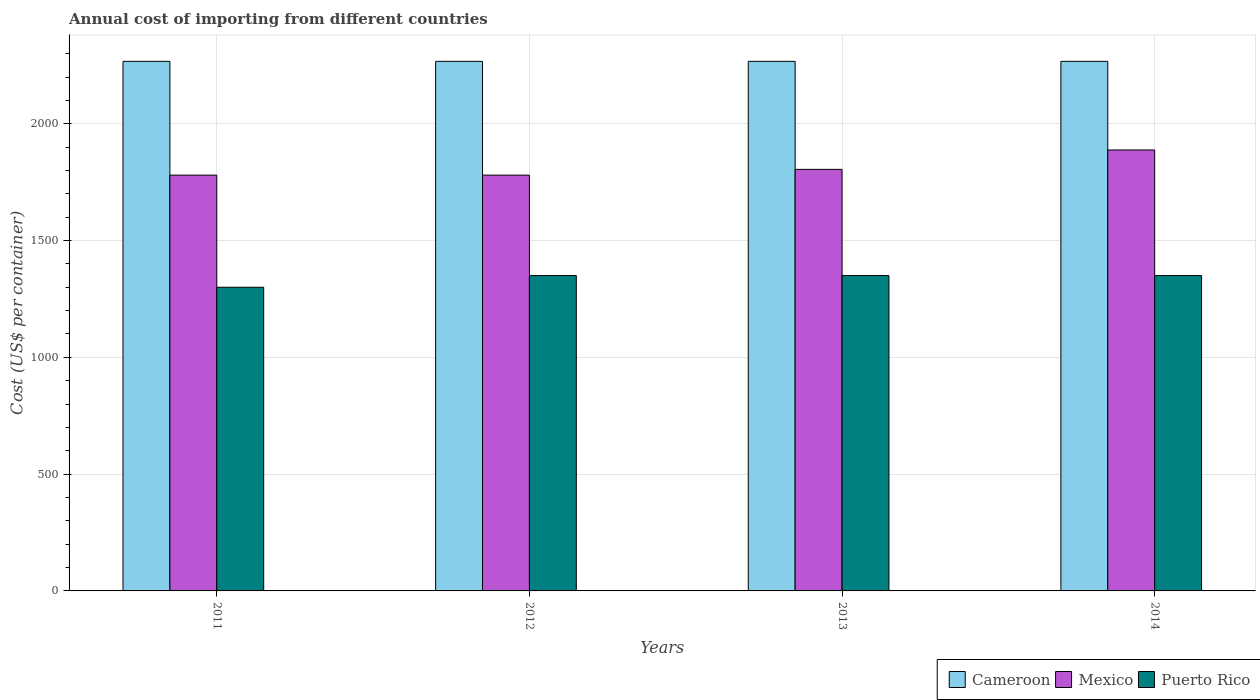How many groups of bars are there?
Give a very brief answer. 4. Are the number of bars per tick equal to the number of legend labels?
Provide a succinct answer. Yes. How many bars are there on the 2nd tick from the left?
Ensure brevity in your answer.  3. How many bars are there on the 1st tick from the right?
Ensure brevity in your answer.  3. What is the label of the 2nd group of bars from the left?
Your answer should be compact. 2012. In how many cases, is the number of bars for a given year not equal to the number of legend labels?
Your answer should be compact. 0. What is the total annual cost of importing in Cameroon in 2012?
Ensure brevity in your answer.  2267. Across all years, what is the maximum total annual cost of importing in Puerto Rico?
Make the answer very short. 1350. Across all years, what is the minimum total annual cost of importing in Cameroon?
Your response must be concise. 2267. What is the total total annual cost of importing in Cameroon in the graph?
Ensure brevity in your answer.  9068. What is the difference between the total annual cost of importing in Puerto Rico in 2013 and that in 2014?
Your answer should be very brief. 0. What is the difference between the total annual cost of importing in Mexico in 2012 and the total annual cost of importing in Puerto Rico in 2013?
Provide a short and direct response. 430. What is the average total annual cost of importing in Puerto Rico per year?
Provide a succinct answer. 1337.5. In the year 2011, what is the difference between the total annual cost of importing in Mexico and total annual cost of importing in Puerto Rico?
Make the answer very short. 480. Is the total annual cost of importing in Puerto Rico in 2011 less than that in 2014?
Offer a very short reply. Yes. Is the difference between the total annual cost of importing in Mexico in 2012 and 2013 greater than the difference between the total annual cost of importing in Puerto Rico in 2012 and 2013?
Give a very brief answer. No. What is the difference between the highest and the second highest total annual cost of importing in Puerto Rico?
Provide a short and direct response. 0. What is the difference between the highest and the lowest total annual cost of importing in Mexico?
Offer a terse response. 107.6. In how many years, is the total annual cost of importing in Mexico greater than the average total annual cost of importing in Mexico taken over all years?
Make the answer very short. 1. What does the 2nd bar from the left in 2013 represents?
Your answer should be compact. Mexico. What does the 1st bar from the right in 2014 represents?
Offer a terse response. Puerto Rico. Is it the case that in every year, the sum of the total annual cost of importing in Cameroon and total annual cost of importing in Mexico is greater than the total annual cost of importing in Puerto Rico?
Provide a short and direct response. Yes. How many bars are there?
Your answer should be compact. 12. Does the graph contain any zero values?
Make the answer very short. No. Where does the legend appear in the graph?
Make the answer very short. Bottom right. How many legend labels are there?
Your answer should be compact. 3. How are the legend labels stacked?
Offer a terse response. Horizontal. What is the title of the graph?
Provide a succinct answer. Annual cost of importing from different countries. Does "Brazil" appear as one of the legend labels in the graph?
Offer a very short reply. No. What is the label or title of the Y-axis?
Provide a short and direct response. Cost (US$ per container). What is the Cost (US$ per container) in Cameroon in 2011?
Make the answer very short. 2267. What is the Cost (US$ per container) in Mexico in 2011?
Offer a very short reply. 1780. What is the Cost (US$ per container) in Puerto Rico in 2011?
Provide a succinct answer. 1300. What is the Cost (US$ per container) in Cameroon in 2012?
Offer a terse response. 2267. What is the Cost (US$ per container) in Mexico in 2012?
Keep it short and to the point. 1780. What is the Cost (US$ per container) of Puerto Rico in 2012?
Offer a very short reply. 1350. What is the Cost (US$ per container) of Cameroon in 2013?
Provide a succinct answer. 2267. What is the Cost (US$ per container) of Mexico in 2013?
Provide a succinct answer. 1804.6. What is the Cost (US$ per container) in Puerto Rico in 2013?
Provide a short and direct response. 1350. What is the Cost (US$ per container) in Cameroon in 2014?
Keep it short and to the point. 2267. What is the Cost (US$ per container) in Mexico in 2014?
Make the answer very short. 1887.6. What is the Cost (US$ per container) in Puerto Rico in 2014?
Keep it short and to the point. 1350. Across all years, what is the maximum Cost (US$ per container) of Cameroon?
Make the answer very short. 2267. Across all years, what is the maximum Cost (US$ per container) in Mexico?
Your answer should be very brief. 1887.6. Across all years, what is the maximum Cost (US$ per container) in Puerto Rico?
Provide a succinct answer. 1350. Across all years, what is the minimum Cost (US$ per container) of Cameroon?
Your answer should be very brief. 2267. Across all years, what is the minimum Cost (US$ per container) of Mexico?
Keep it short and to the point. 1780. Across all years, what is the minimum Cost (US$ per container) in Puerto Rico?
Make the answer very short. 1300. What is the total Cost (US$ per container) of Cameroon in the graph?
Give a very brief answer. 9068. What is the total Cost (US$ per container) in Mexico in the graph?
Offer a very short reply. 7252.2. What is the total Cost (US$ per container) of Puerto Rico in the graph?
Provide a short and direct response. 5350. What is the difference between the Cost (US$ per container) of Cameroon in 2011 and that in 2012?
Provide a succinct answer. 0. What is the difference between the Cost (US$ per container) of Puerto Rico in 2011 and that in 2012?
Your answer should be compact. -50. What is the difference between the Cost (US$ per container) in Cameroon in 2011 and that in 2013?
Your response must be concise. 0. What is the difference between the Cost (US$ per container) of Mexico in 2011 and that in 2013?
Keep it short and to the point. -24.6. What is the difference between the Cost (US$ per container) in Puerto Rico in 2011 and that in 2013?
Your answer should be compact. -50. What is the difference between the Cost (US$ per container) of Mexico in 2011 and that in 2014?
Give a very brief answer. -107.6. What is the difference between the Cost (US$ per container) in Puerto Rico in 2011 and that in 2014?
Provide a succinct answer. -50. What is the difference between the Cost (US$ per container) in Mexico in 2012 and that in 2013?
Keep it short and to the point. -24.6. What is the difference between the Cost (US$ per container) of Cameroon in 2012 and that in 2014?
Make the answer very short. 0. What is the difference between the Cost (US$ per container) of Mexico in 2012 and that in 2014?
Keep it short and to the point. -107.6. What is the difference between the Cost (US$ per container) of Mexico in 2013 and that in 2014?
Offer a very short reply. -83. What is the difference between the Cost (US$ per container) of Puerto Rico in 2013 and that in 2014?
Your response must be concise. 0. What is the difference between the Cost (US$ per container) of Cameroon in 2011 and the Cost (US$ per container) of Mexico in 2012?
Offer a terse response. 487. What is the difference between the Cost (US$ per container) in Cameroon in 2011 and the Cost (US$ per container) in Puerto Rico in 2012?
Your answer should be very brief. 917. What is the difference between the Cost (US$ per container) in Mexico in 2011 and the Cost (US$ per container) in Puerto Rico in 2012?
Keep it short and to the point. 430. What is the difference between the Cost (US$ per container) in Cameroon in 2011 and the Cost (US$ per container) in Mexico in 2013?
Give a very brief answer. 462.4. What is the difference between the Cost (US$ per container) of Cameroon in 2011 and the Cost (US$ per container) of Puerto Rico in 2013?
Make the answer very short. 917. What is the difference between the Cost (US$ per container) of Mexico in 2011 and the Cost (US$ per container) of Puerto Rico in 2013?
Keep it short and to the point. 430. What is the difference between the Cost (US$ per container) in Cameroon in 2011 and the Cost (US$ per container) in Mexico in 2014?
Offer a terse response. 379.4. What is the difference between the Cost (US$ per container) of Cameroon in 2011 and the Cost (US$ per container) of Puerto Rico in 2014?
Give a very brief answer. 917. What is the difference between the Cost (US$ per container) of Mexico in 2011 and the Cost (US$ per container) of Puerto Rico in 2014?
Your answer should be compact. 430. What is the difference between the Cost (US$ per container) of Cameroon in 2012 and the Cost (US$ per container) of Mexico in 2013?
Ensure brevity in your answer.  462.4. What is the difference between the Cost (US$ per container) of Cameroon in 2012 and the Cost (US$ per container) of Puerto Rico in 2013?
Offer a terse response. 917. What is the difference between the Cost (US$ per container) in Mexico in 2012 and the Cost (US$ per container) in Puerto Rico in 2013?
Ensure brevity in your answer.  430. What is the difference between the Cost (US$ per container) of Cameroon in 2012 and the Cost (US$ per container) of Mexico in 2014?
Provide a succinct answer. 379.4. What is the difference between the Cost (US$ per container) in Cameroon in 2012 and the Cost (US$ per container) in Puerto Rico in 2014?
Your response must be concise. 917. What is the difference between the Cost (US$ per container) in Mexico in 2012 and the Cost (US$ per container) in Puerto Rico in 2014?
Make the answer very short. 430. What is the difference between the Cost (US$ per container) of Cameroon in 2013 and the Cost (US$ per container) of Mexico in 2014?
Provide a succinct answer. 379.4. What is the difference between the Cost (US$ per container) of Cameroon in 2013 and the Cost (US$ per container) of Puerto Rico in 2014?
Your response must be concise. 917. What is the difference between the Cost (US$ per container) of Mexico in 2013 and the Cost (US$ per container) of Puerto Rico in 2014?
Offer a very short reply. 454.6. What is the average Cost (US$ per container) in Cameroon per year?
Provide a short and direct response. 2267. What is the average Cost (US$ per container) of Mexico per year?
Offer a terse response. 1813.05. What is the average Cost (US$ per container) of Puerto Rico per year?
Your answer should be very brief. 1337.5. In the year 2011, what is the difference between the Cost (US$ per container) in Cameroon and Cost (US$ per container) in Mexico?
Your response must be concise. 487. In the year 2011, what is the difference between the Cost (US$ per container) of Cameroon and Cost (US$ per container) of Puerto Rico?
Offer a terse response. 967. In the year 2011, what is the difference between the Cost (US$ per container) in Mexico and Cost (US$ per container) in Puerto Rico?
Your response must be concise. 480. In the year 2012, what is the difference between the Cost (US$ per container) in Cameroon and Cost (US$ per container) in Mexico?
Make the answer very short. 487. In the year 2012, what is the difference between the Cost (US$ per container) of Cameroon and Cost (US$ per container) of Puerto Rico?
Provide a short and direct response. 917. In the year 2012, what is the difference between the Cost (US$ per container) in Mexico and Cost (US$ per container) in Puerto Rico?
Keep it short and to the point. 430. In the year 2013, what is the difference between the Cost (US$ per container) of Cameroon and Cost (US$ per container) of Mexico?
Offer a terse response. 462.4. In the year 2013, what is the difference between the Cost (US$ per container) in Cameroon and Cost (US$ per container) in Puerto Rico?
Ensure brevity in your answer.  917. In the year 2013, what is the difference between the Cost (US$ per container) in Mexico and Cost (US$ per container) in Puerto Rico?
Your response must be concise. 454.6. In the year 2014, what is the difference between the Cost (US$ per container) in Cameroon and Cost (US$ per container) in Mexico?
Provide a short and direct response. 379.4. In the year 2014, what is the difference between the Cost (US$ per container) of Cameroon and Cost (US$ per container) of Puerto Rico?
Ensure brevity in your answer.  917. In the year 2014, what is the difference between the Cost (US$ per container) in Mexico and Cost (US$ per container) in Puerto Rico?
Keep it short and to the point. 537.6. What is the ratio of the Cost (US$ per container) of Mexico in 2011 to that in 2012?
Offer a terse response. 1. What is the ratio of the Cost (US$ per container) in Puerto Rico in 2011 to that in 2012?
Provide a succinct answer. 0.96. What is the ratio of the Cost (US$ per container) of Mexico in 2011 to that in 2013?
Make the answer very short. 0.99. What is the ratio of the Cost (US$ per container) of Mexico in 2011 to that in 2014?
Offer a terse response. 0.94. What is the ratio of the Cost (US$ per container) of Puerto Rico in 2011 to that in 2014?
Provide a succinct answer. 0.96. What is the ratio of the Cost (US$ per container) in Mexico in 2012 to that in 2013?
Your answer should be compact. 0.99. What is the ratio of the Cost (US$ per container) in Mexico in 2012 to that in 2014?
Your answer should be compact. 0.94. What is the ratio of the Cost (US$ per container) of Puerto Rico in 2012 to that in 2014?
Your answer should be compact. 1. What is the ratio of the Cost (US$ per container) of Cameroon in 2013 to that in 2014?
Provide a short and direct response. 1. What is the ratio of the Cost (US$ per container) of Mexico in 2013 to that in 2014?
Provide a succinct answer. 0.96. What is the ratio of the Cost (US$ per container) in Puerto Rico in 2013 to that in 2014?
Keep it short and to the point. 1. What is the difference between the highest and the second highest Cost (US$ per container) in Cameroon?
Offer a terse response. 0. What is the difference between the highest and the second highest Cost (US$ per container) of Mexico?
Your answer should be very brief. 83. What is the difference between the highest and the second highest Cost (US$ per container) of Puerto Rico?
Provide a succinct answer. 0. What is the difference between the highest and the lowest Cost (US$ per container) in Mexico?
Provide a succinct answer. 107.6. 